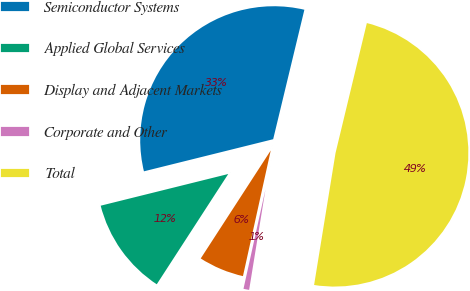Convert chart to OTSL. <chart><loc_0><loc_0><loc_500><loc_500><pie_chart><fcel>Semiconductor Systems<fcel>Applied Global Services<fcel>Display and Adjacent Markets<fcel>Corporate and Other<fcel>Total<nl><fcel>32.64%<fcel>11.97%<fcel>5.69%<fcel>0.9%<fcel>48.8%<nl></chart> 